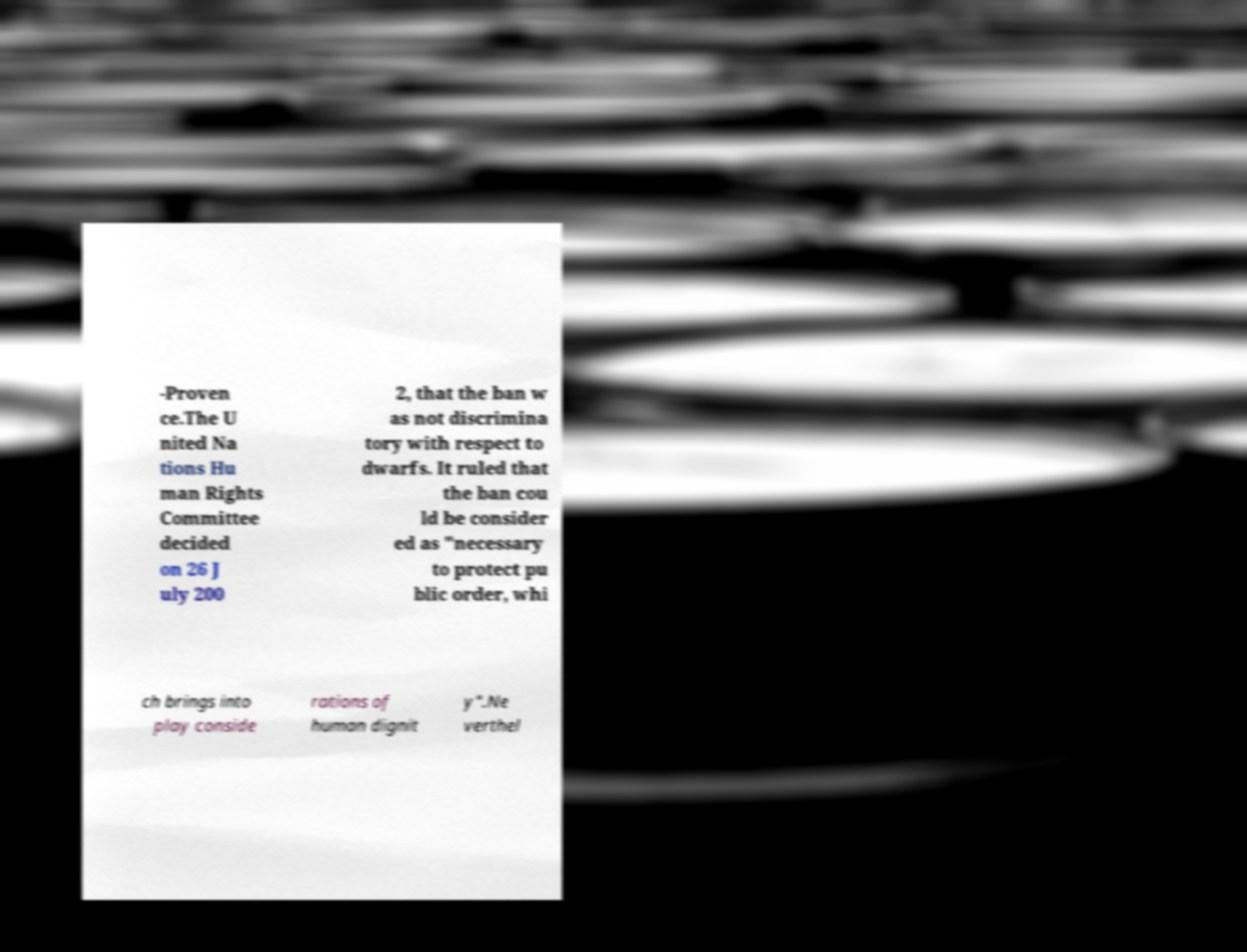Could you assist in decoding the text presented in this image and type it out clearly? -Proven ce.The U nited Na tions Hu man Rights Committee decided on 26 J uly 200 2, that the ban w as not discrimina tory with respect to dwarfs. It ruled that the ban cou ld be consider ed as "necessary to protect pu blic order, whi ch brings into play conside rations of human dignit y".Ne verthel 